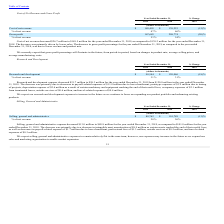According to Maxlinear's financial document, Why is the selling, general and administrative expenses expected to increase in the future? as we expand our sales and marketing organization to enable market expansion.. The document states: "; however, our expenses may increase in the future as we expand our sales and marketing organization to enable market expansion. 51..." Also, can you calculate: What is the average Selling, general and administrative for the Years Ended December 31, 2019 to 2018? To answer this question, I need to perform calculations using the financial data. The calculation is: (88,762+101,789) / 2, which equals 95275.5 (in thousands). This is based on the information: "Selling, general and administrative $ 88,762 $ 101,789 (13)% Selling, general and administrative $ 88,762 $ 101,789 (13)%..." The key data points involved are: 101,789, 88,762. Also, can you calculate: What is the average % of net revenue for the Years Ended December 31, 2019 to 2018? To answer this question, I need to perform calculations using the financial data. The calculation is: (28+26) / 2, which equals 27 (percentage). This is based on the information: "% of net revenue 28% 26% % of net revenue 28% 26%..." The key data points involved are: 26, 28. Additionally, In which year was Selling, general and administrative less than 100,000 thousands? According to the financial document, 2019. The relevant text states: "2019 2018 2019..." Also, What was the respective % of net revenue in 2019 and 2018? The document shows two values: 28% and 26%. From the document: "% of net revenue 28% 26% % of net revenue 28% 26%..." Also, What was the decrease in Selling, general and administrative in 2019? According to the financial document, $13.0 million. The relevant text states: "ling, general and administrative expense decreased $13.0 million to $88.8 million for the year ended December 31, 2019, as compared to $101.8 million for the year..." 